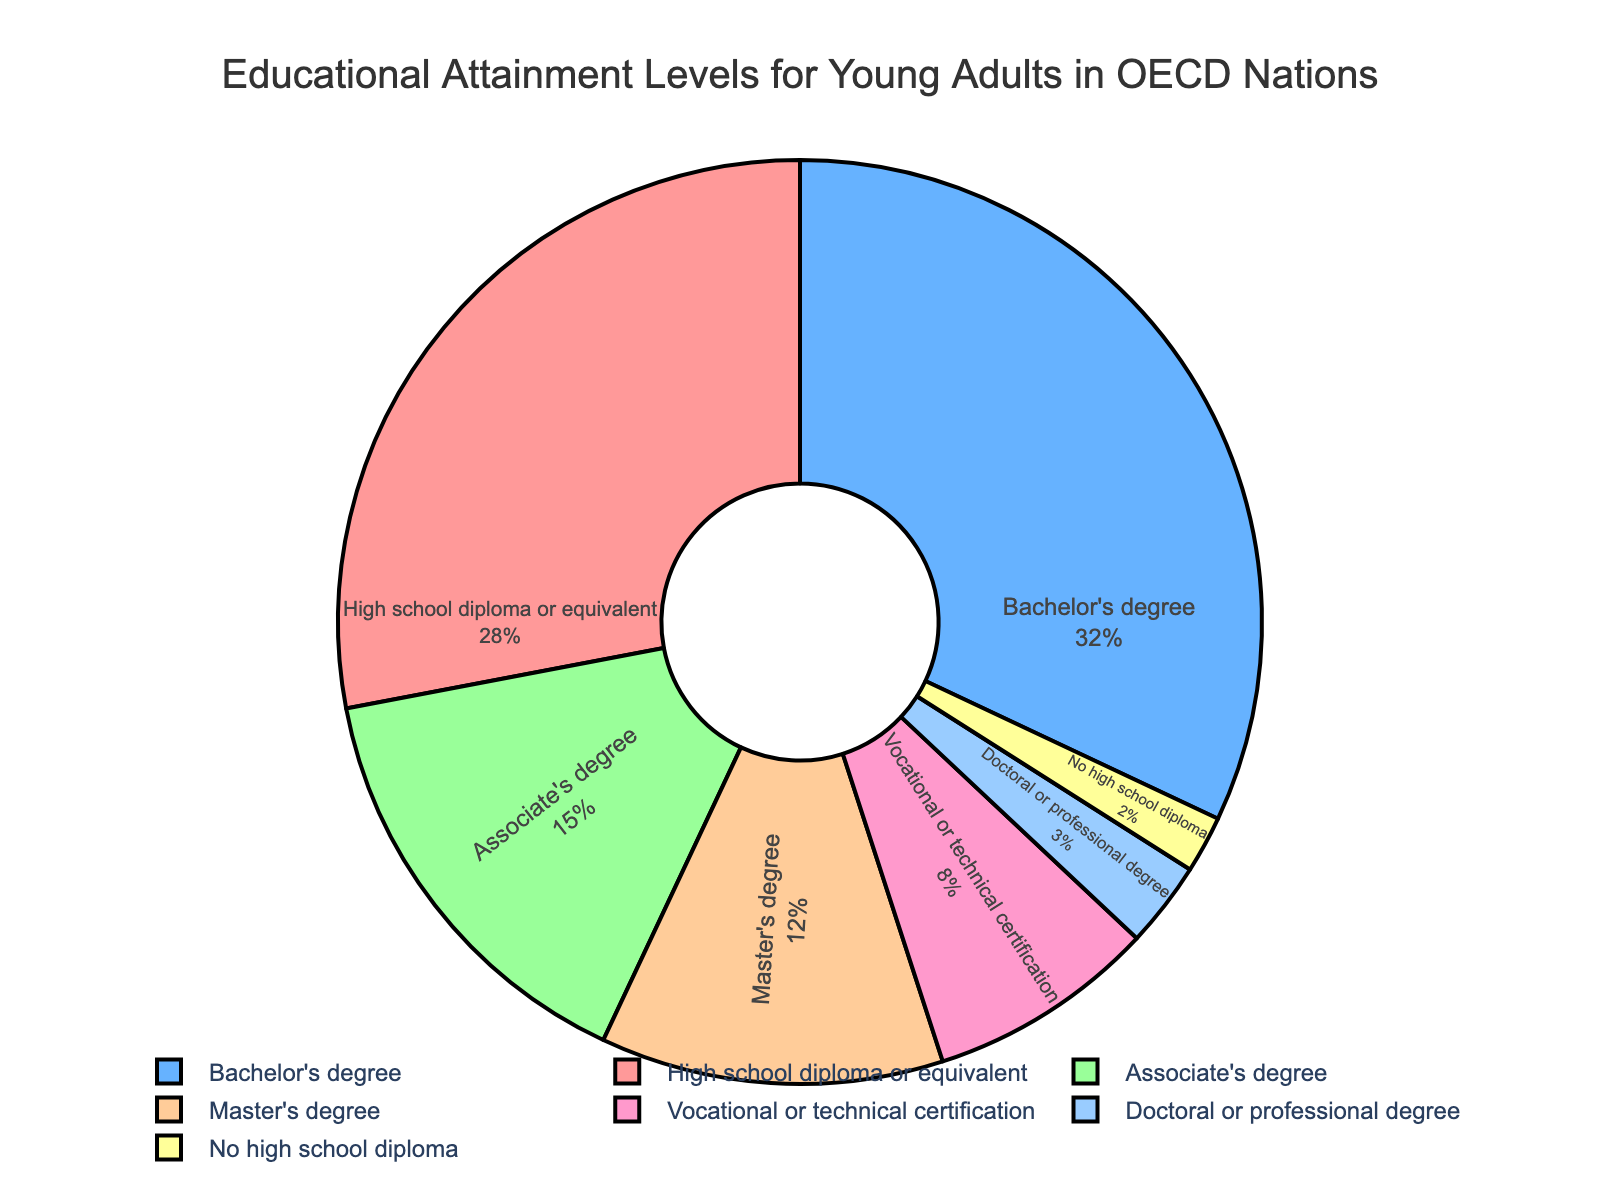What is the most common level of educational attainment? The pie chart shows that the largest segment is labeled "Bachelor's degree" with a percentage of 32%, indicating this is the most common level of educational attainment for young adults in OECD nations.
Answer: Bachelor's degree Which educational attainment level is more common, Master's degree or Associate's degree? The pie chart shows the percentage for Master's degree is 12%, while for Associate's degree it is 15%. Therefore, Associate's degree is more common.
Answer: Associate's degree What percentage of young adults in OECD nations do not have a high school diploma? The pie chart segment labeled "No high school diploma" represents 2% of the total, indicating the percentage of young adults without a high school diploma.
Answer: 2% Which two levels of educational attainment combined make up more than half of the total percentage? The Bachelor's degree accounts for 32% and the High school diploma or equivalent accounts for 28%. Adding these together (32% + 28%) gives 60%, which is more than half of the total.
Answer: Bachelor's degree and High school diploma or equivalent Compare the combined percentage of Vocational or technical certification, and Doctoral or professional degree to that of Master's degree. Which is higher? Vocational or technical certification is 8% and Doctoral or professional degree is 3%. Their combined percentage is 11% (8% + 3%). This is lower than the Master's degree percentage of 12%.
Answer: Master's degree What is the difference in percentage points between the highest and lowest levels of educational attainment? The highest level of educational attainment is Bachelor's degree at 32%, and the lowest is No high school diploma at 2%. The difference is 32% - 2% = 30%.
Answer: 30 percentage points If the percentages of Bachelor's degree, Associate's degree, and Master's degree are summed, what is the total and how does it compare to half of the total percentage (50%)? Summing these percentages: Bachelor's degree (32%) + Associate's degree (15%) + Master's degree (12%) gives 59%. This is greater than 50%.
Answer: 59%, greater than 50% What proportion of young adults have attained a Master's degree, Doctoral or professional degree, and no high school diploma combined? Summing these percentages: Master's degree (12%) + Doctoral or professional degree (3%) + No high school diploma (2%) gives 17%.
Answer: 17% Is there a larger percentage of young adults with vocational or technical certification than with a Doctoral or professional degree? The pie chart shows that the percentage for Vocational or technical certification is 8%, while for Doctoral or professional degree it is 3%. Therefore, there is a larger percentage with Vocational or technical certification.
Answer: Yes 